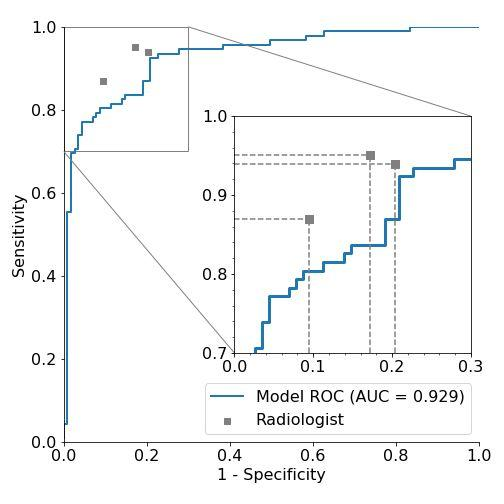Based on the AUC (Area Under the Curve) value provided in the figure, how would you classify the model's performance? A. Poor B. Fair C. Good D. Excellent The AUC value shown in the image is 0.929. The Area Under the Curve (AUC) is a performance measurement for classification models at various threshold settings. AUC measures the ability of the model to distinguish between classes and is used as a summary of the ROC curve. A higher AUC value, close to 1, generally indicates better model performance. In this case, an AUC of 0.929 is excellent as it's close to 1, indicating that the model performs exceptionally well in distinguishing between the two conditions. Therefore, the correct answer is D. Excellent. 